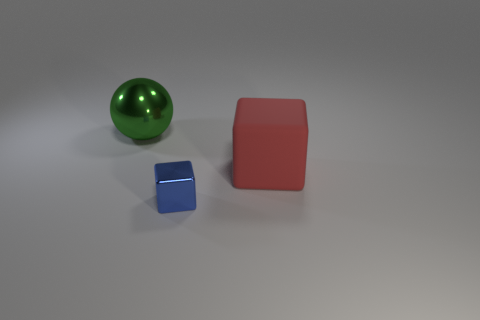Subtract all red blocks. How many blocks are left? 1 Add 2 big gray cylinders. How many objects exist? 5 Subtract all blocks. How many objects are left? 1 Subtract 1 red blocks. How many objects are left? 2 Subtract all big red spheres. Subtract all big green balls. How many objects are left? 2 Add 1 matte things. How many matte things are left? 2 Add 1 tiny metallic things. How many tiny metallic things exist? 2 